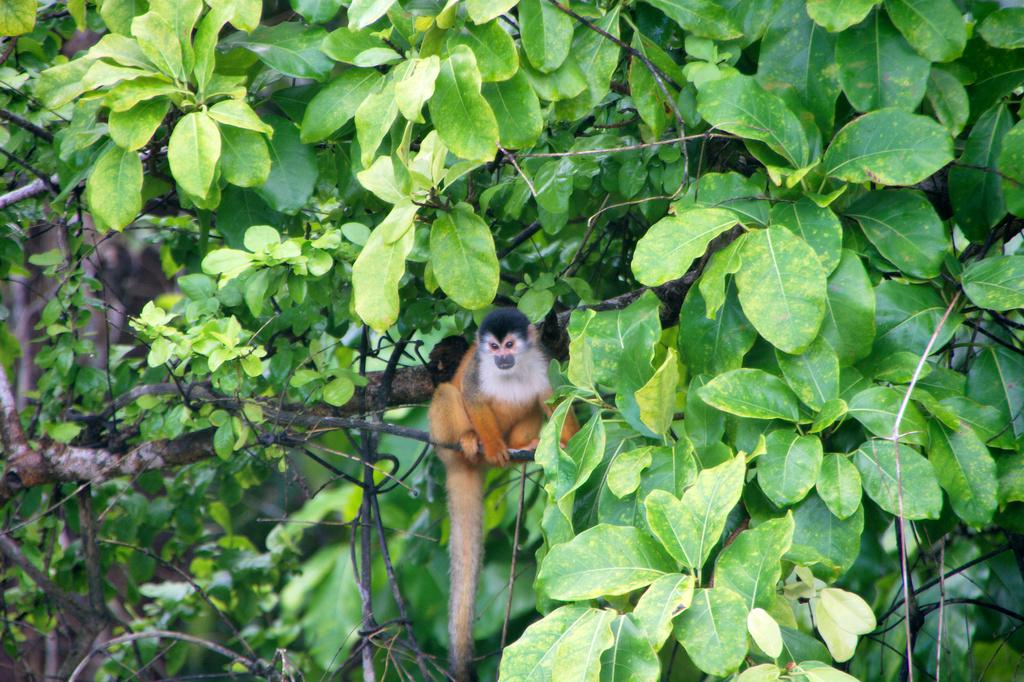What is present in the image that represents a living organism in nature? There is a tree in the image. What is the color of the tree in the image? The tree is green in color. Is there any other living organism present on the tree? Yes, there is an animal on the tree. What colors can be seen on the animal? The animal has white, orange, and black colors. What point does the riddle in the image make about the animal's habitat? There is no riddle present in the image, and therefore no point can be made about the animal's habitat. 